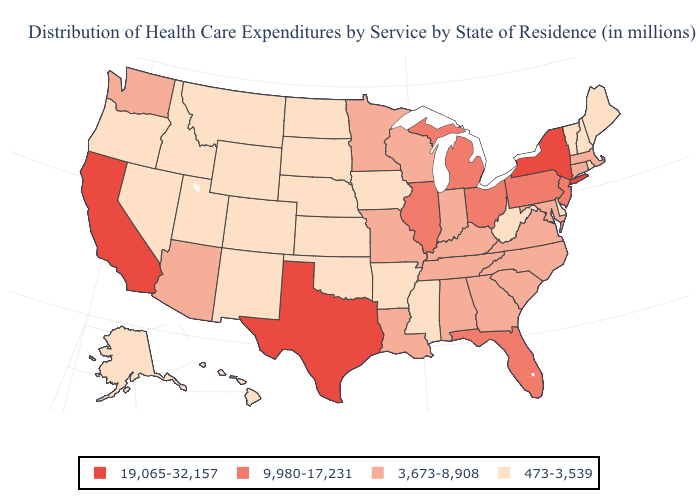Among the states that border Delaware , which have the highest value?
Short answer required. New Jersey, Pennsylvania. Name the states that have a value in the range 473-3,539?
Be succinct. Alaska, Arkansas, Colorado, Delaware, Hawaii, Idaho, Iowa, Kansas, Maine, Mississippi, Montana, Nebraska, Nevada, New Hampshire, New Mexico, North Dakota, Oklahoma, Oregon, Rhode Island, South Dakota, Utah, Vermont, West Virginia, Wyoming. Which states have the lowest value in the USA?
Short answer required. Alaska, Arkansas, Colorado, Delaware, Hawaii, Idaho, Iowa, Kansas, Maine, Mississippi, Montana, Nebraska, Nevada, New Hampshire, New Mexico, North Dakota, Oklahoma, Oregon, Rhode Island, South Dakota, Utah, Vermont, West Virginia, Wyoming. Does New York have the highest value in the Northeast?
Concise answer only. Yes. Does Kentucky have a lower value than Vermont?
Answer briefly. No. Name the states that have a value in the range 19,065-32,157?
Concise answer only. California, New York, Texas. Name the states that have a value in the range 473-3,539?
Be succinct. Alaska, Arkansas, Colorado, Delaware, Hawaii, Idaho, Iowa, Kansas, Maine, Mississippi, Montana, Nebraska, Nevada, New Hampshire, New Mexico, North Dakota, Oklahoma, Oregon, Rhode Island, South Dakota, Utah, Vermont, West Virginia, Wyoming. Is the legend a continuous bar?
Give a very brief answer. No. What is the highest value in the West ?
Write a very short answer. 19,065-32,157. Does the map have missing data?
Give a very brief answer. No. Name the states that have a value in the range 3,673-8,908?
Concise answer only. Alabama, Arizona, Connecticut, Georgia, Indiana, Kentucky, Louisiana, Maryland, Massachusetts, Minnesota, Missouri, North Carolina, South Carolina, Tennessee, Virginia, Washington, Wisconsin. What is the value of North Dakota?
Answer briefly. 473-3,539. Name the states that have a value in the range 473-3,539?
Give a very brief answer. Alaska, Arkansas, Colorado, Delaware, Hawaii, Idaho, Iowa, Kansas, Maine, Mississippi, Montana, Nebraska, Nevada, New Hampshire, New Mexico, North Dakota, Oklahoma, Oregon, Rhode Island, South Dakota, Utah, Vermont, West Virginia, Wyoming. Which states have the lowest value in the MidWest?
Answer briefly. Iowa, Kansas, Nebraska, North Dakota, South Dakota. Among the states that border Arizona , which have the highest value?
Give a very brief answer. California. 